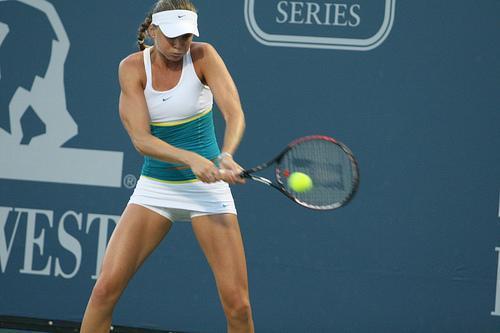How many tennis balls are visible?
Give a very brief answer. 1. 